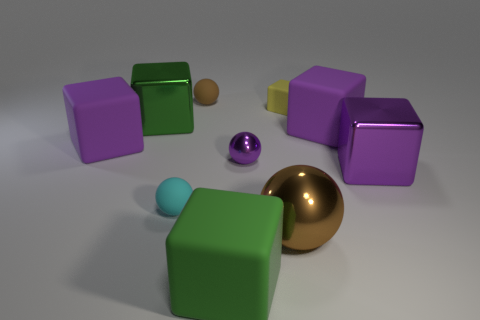Subtract all purple cubes. How many were subtracted if there are1purple cubes left? 2 Subtract all yellow cylinders. How many purple blocks are left? 3 Subtract 1 cubes. How many cubes are left? 5 Subtract all yellow blocks. How many blocks are left? 5 Subtract all small cubes. How many cubes are left? 5 Subtract all red cubes. Subtract all cyan cylinders. How many cubes are left? 6 Subtract all cubes. How many objects are left? 4 Add 6 brown balls. How many brown balls exist? 8 Subtract 0 brown cubes. How many objects are left? 10 Subtract all small purple matte spheres. Subtract all big purple metal blocks. How many objects are left? 9 